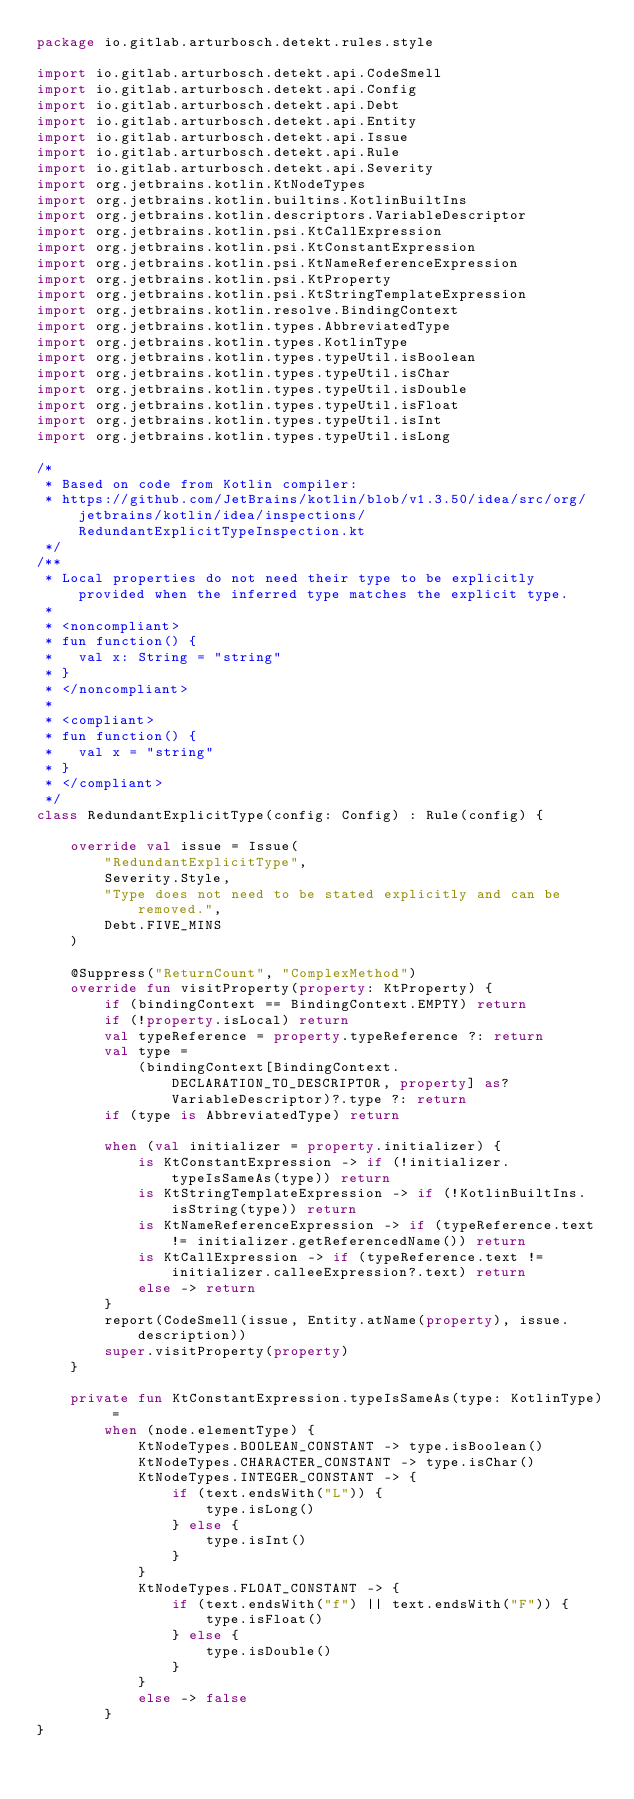<code> <loc_0><loc_0><loc_500><loc_500><_Kotlin_>package io.gitlab.arturbosch.detekt.rules.style

import io.gitlab.arturbosch.detekt.api.CodeSmell
import io.gitlab.arturbosch.detekt.api.Config
import io.gitlab.arturbosch.detekt.api.Debt
import io.gitlab.arturbosch.detekt.api.Entity
import io.gitlab.arturbosch.detekt.api.Issue
import io.gitlab.arturbosch.detekt.api.Rule
import io.gitlab.arturbosch.detekt.api.Severity
import org.jetbrains.kotlin.KtNodeTypes
import org.jetbrains.kotlin.builtins.KotlinBuiltIns
import org.jetbrains.kotlin.descriptors.VariableDescriptor
import org.jetbrains.kotlin.psi.KtCallExpression
import org.jetbrains.kotlin.psi.KtConstantExpression
import org.jetbrains.kotlin.psi.KtNameReferenceExpression
import org.jetbrains.kotlin.psi.KtProperty
import org.jetbrains.kotlin.psi.KtStringTemplateExpression
import org.jetbrains.kotlin.resolve.BindingContext
import org.jetbrains.kotlin.types.AbbreviatedType
import org.jetbrains.kotlin.types.KotlinType
import org.jetbrains.kotlin.types.typeUtil.isBoolean
import org.jetbrains.kotlin.types.typeUtil.isChar
import org.jetbrains.kotlin.types.typeUtil.isDouble
import org.jetbrains.kotlin.types.typeUtil.isFloat
import org.jetbrains.kotlin.types.typeUtil.isInt
import org.jetbrains.kotlin.types.typeUtil.isLong

/*
 * Based on code from Kotlin compiler:
 * https://github.com/JetBrains/kotlin/blob/v1.3.50/idea/src/org/jetbrains/kotlin/idea/inspections/RedundantExplicitTypeInspection.kt
 */
/**
 * Local properties do not need their type to be explicitly provided when the inferred type matches the explicit type.
 *
 * <noncompliant>
 * fun function() {
 *   val x: String = "string"
 * }
 * </noncompliant>
 *
 * <compliant>
 * fun function() {
 *   val x = "string"
 * }
 * </compliant>
 */
class RedundantExplicitType(config: Config) : Rule(config) {

    override val issue = Issue(
        "RedundantExplicitType",
        Severity.Style,
        "Type does not need to be stated explicitly and can be removed.",
        Debt.FIVE_MINS
    )

    @Suppress("ReturnCount", "ComplexMethod")
    override fun visitProperty(property: KtProperty) {
        if (bindingContext == BindingContext.EMPTY) return
        if (!property.isLocal) return
        val typeReference = property.typeReference ?: return
        val type =
            (bindingContext[BindingContext.DECLARATION_TO_DESCRIPTOR, property] as? VariableDescriptor)?.type ?: return
        if (type is AbbreviatedType) return

        when (val initializer = property.initializer) {
            is KtConstantExpression -> if (!initializer.typeIsSameAs(type)) return
            is KtStringTemplateExpression -> if (!KotlinBuiltIns.isString(type)) return
            is KtNameReferenceExpression -> if (typeReference.text != initializer.getReferencedName()) return
            is KtCallExpression -> if (typeReference.text != initializer.calleeExpression?.text) return
            else -> return
        }
        report(CodeSmell(issue, Entity.atName(property), issue.description))
        super.visitProperty(property)
    }

    private fun KtConstantExpression.typeIsSameAs(type: KotlinType) =
        when (node.elementType) {
            KtNodeTypes.BOOLEAN_CONSTANT -> type.isBoolean()
            KtNodeTypes.CHARACTER_CONSTANT -> type.isChar()
            KtNodeTypes.INTEGER_CONSTANT -> {
                if (text.endsWith("L")) {
                    type.isLong()
                } else {
                    type.isInt()
                }
            }
            KtNodeTypes.FLOAT_CONSTANT -> {
                if (text.endsWith("f") || text.endsWith("F")) {
                    type.isFloat()
                } else {
                    type.isDouble()
                }
            }
            else -> false
        }
}
</code> 